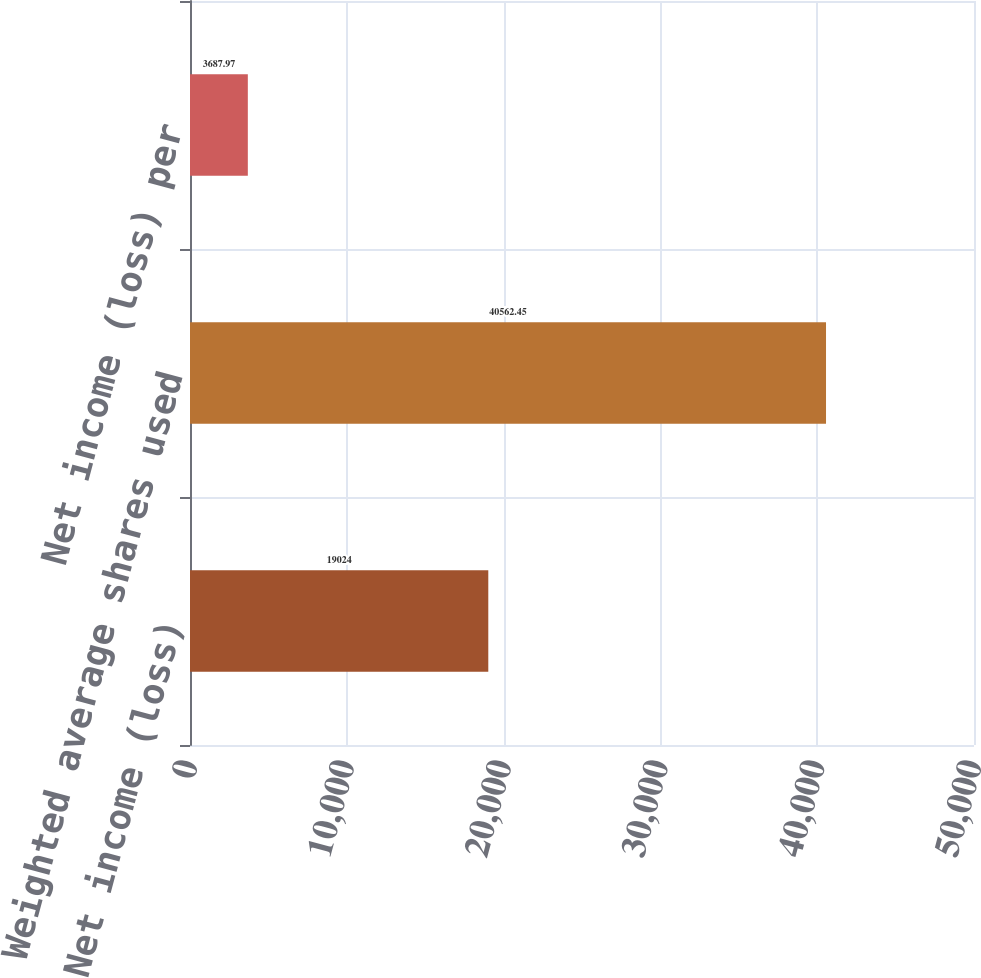<chart> <loc_0><loc_0><loc_500><loc_500><bar_chart><fcel>Net income (loss)<fcel>Weighted average shares used<fcel>Net income (loss) per<nl><fcel>19024<fcel>40562.4<fcel>3687.97<nl></chart> 